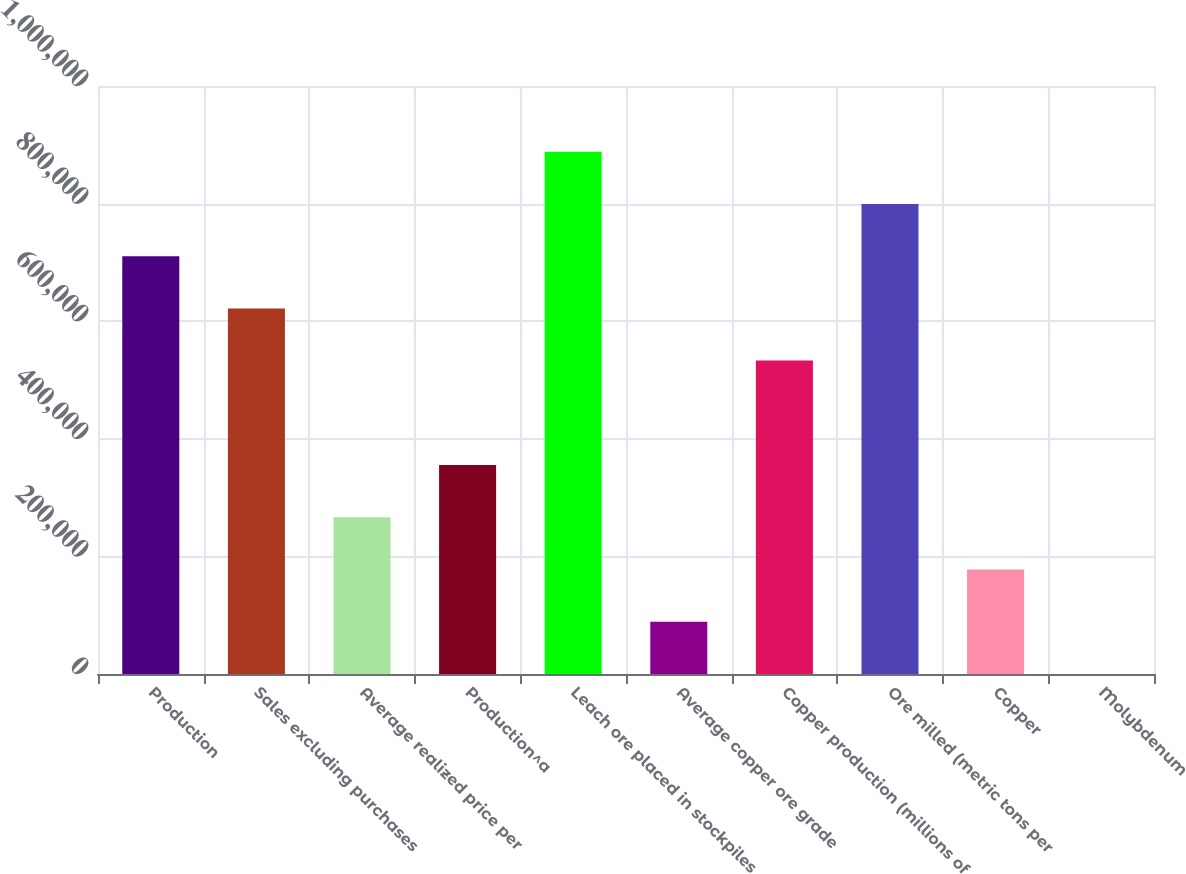Convert chart to OTSL. <chart><loc_0><loc_0><loc_500><loc_500><bar_chart><fcel>Production<fcel>Sales excluding purchases<fcel>Average realized price per<fcel>Production^a<fcel>Leach ore placed in stockpiles<fcel>Average copper ore grade<fcel>Copper production (millions of<fcel>Ore milled (metric tons per<fcel>Copper<fcel>Molybdenum<nl><fcel>710640<fcel>621810<fcel>266490<fcel>355320<fcel>888300<fcel>88830<fcel>532980<fcel>799470<fcel>177660<fcel>0.03<nl></chart> 